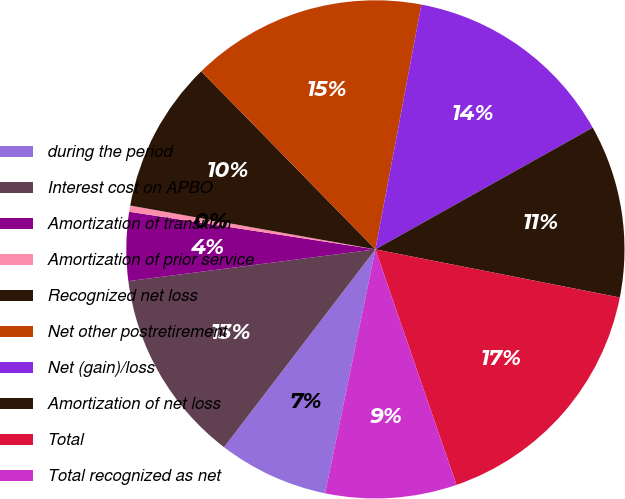<chart> <loc_0><loc_0><loc_500><loc_500><pie_chart><fcel>during the period<fcel>Interest cost on APBO<fcel>Amortization of transition<fcel>Amortization of prior service<fcel>Recognized net loss<fcel>Net other postretirement<fcel>Net (gain)/loss<fcel>Amortization of net loss<fcel>Total<fcel>Total recognized as net<nl><fcel>7.16%<fcel>12.57%<fcel>4.45%<fcel>0.4%<fcel>9.86%<fcel>15.28%<fcel>13.92%<fcel>11.22%<fcel>16.63%<fcel>8.51%<nl></chart> 